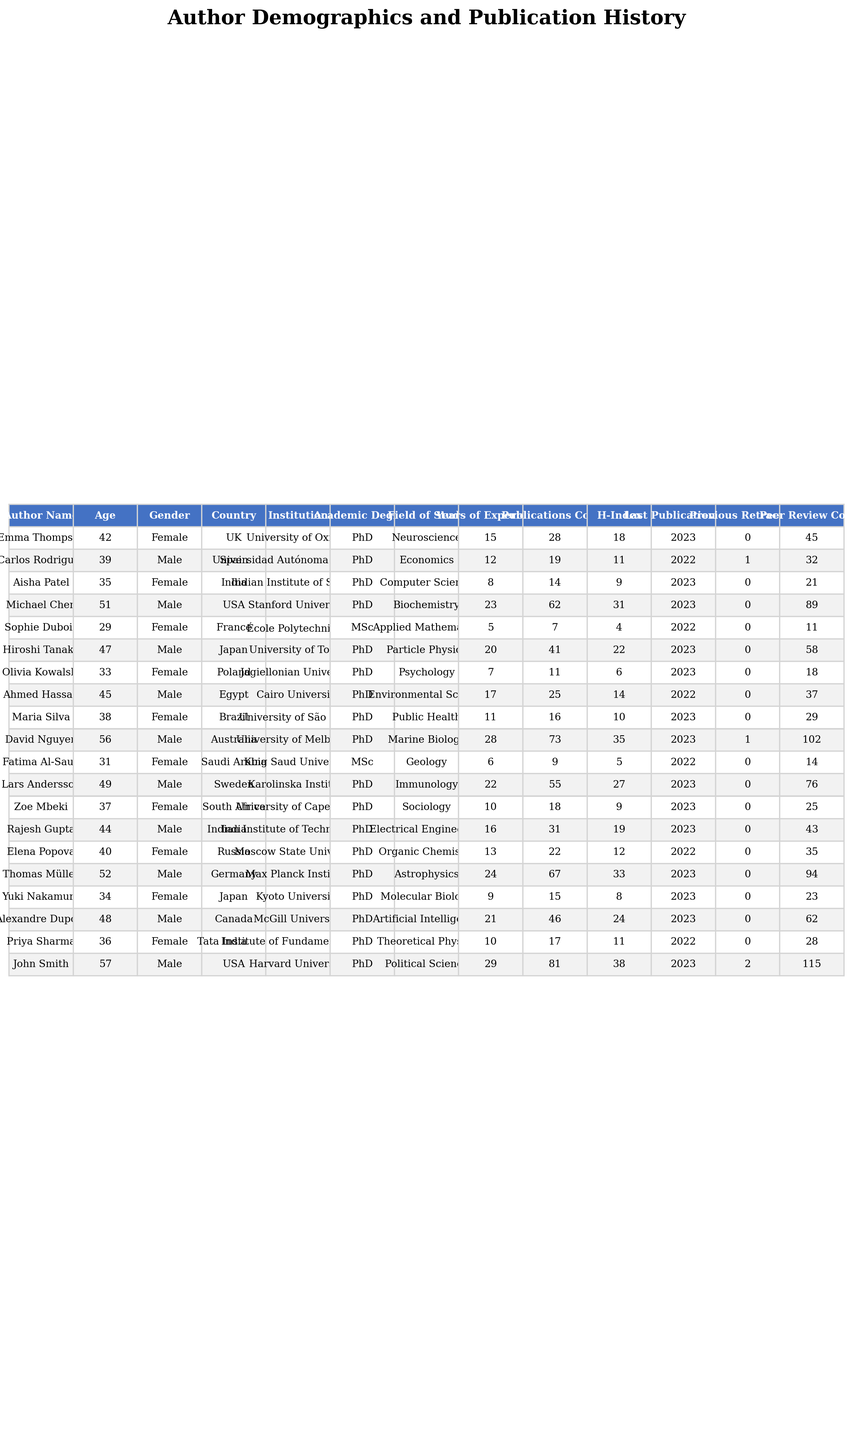What is the age of Michael Chen? Michael Chen's entry in the table shows that his age is listed as 51 years.
Answer: 51 How many publications does John Smith have? Looking at the table, John Smith has a publications count of 81.
Answer: 81 Is there any author who has previously had retractions? By checking the "Previous Retractions" column, there are two instances (for Carlos Rodriguez and John Smith) where authors have retractions.
Answer: Yes What is the average age of the contributors in the table? To calculate the average age, first add all ages: (42 + 39 + 35 + 51 + 29 + 47 + 33 + 45 + 38 + 56 + 31 + 49 + 37 + 44 + 40 + 52 + 34 + 48 + 36 + 57) = 747. There are 20 contributors, so the average age is 747 / 20 = 37.35, which can be rounded to 37.
Answer: 37 How many authors have an H-Index greater than 30? Count the authors with H-Index greater than 30. These are Michael Chen, David Nguyen, John Smith, Thomas Müller, and Lars Andersson, totaling 5 authors.
Answer: 5 Which gender has more contributors in the table? By checking the gender breakdown, there are 10 males and 10 females listed in the table, which indicates an equal number of contributors from both genders.
Answer: Equal What is the total number of publications among contributors from India? The contributors from India are Aisha Patel (14), Rajesh Gupta (31), and Priya Sharma (17). Adding these gives: 14 + 31 + 17 = 62.
Answer: 62 What is the difference in H-Index between the highest and lowest H-Index in the table? The highest H-Index is 115 (John Smith), and the lowest is 4 (Sophie Dubois). The difference is 115 - 4 = 111.
Answer: 111 How many authors are associated with an institution located in the USA? The institutions in the USA from the table are Stanford University (Michael Chen), Harvard University (John Smith), and the total count is 2 authors.
Answer: 2 Are there any authors with more than one previous retraction? Checking the "Previous Retractions" column shows that only John Smith has more than one. Thus, the answer is yes.
Answer: Yes 